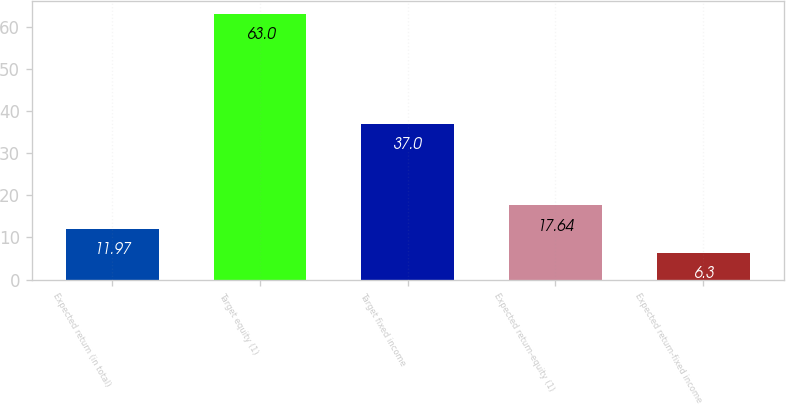Convert chart. <chart><loc_0><loc_0><loc_500><loc_500><bar_chart><fcel>Expected return (in total)<fcel>Target equity (1)<fcel>Target fixed income<fcel>Expected return-equity (1)<fcel>Expected return-fixed income<nl><fcel>11.97<fcel>63<fcel>37<fcel>17.64<fcel>6.3<nl></chart> 